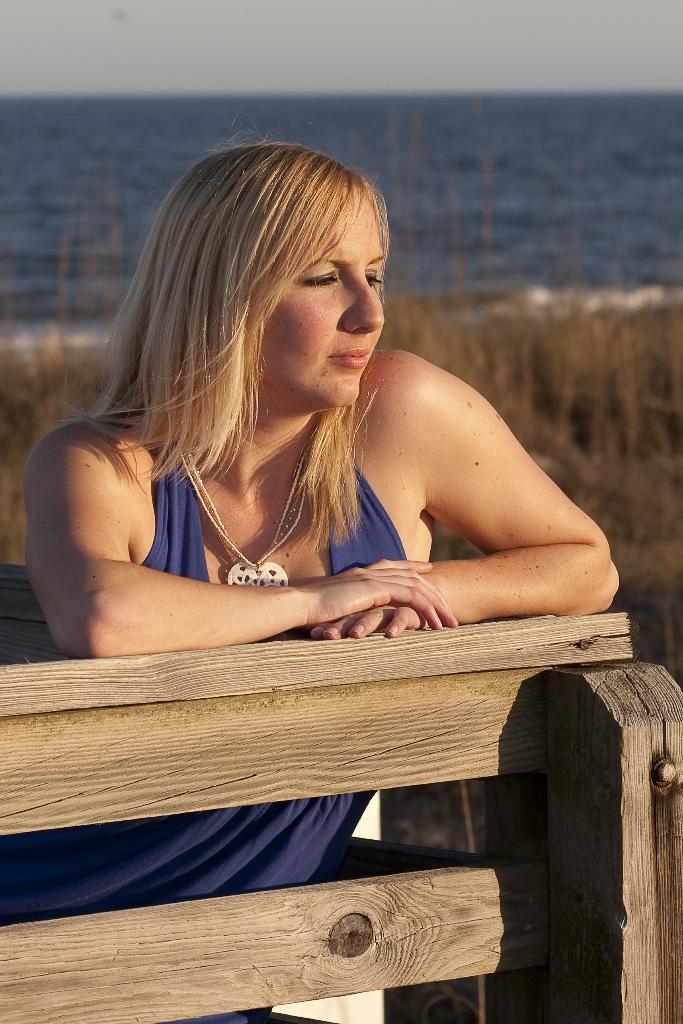Describe this image in one or two sentences. In this image we can see a person sitting on the bench. There are many plants in the image. We can see the sea in the image. We can see the sky at the top of the image. 